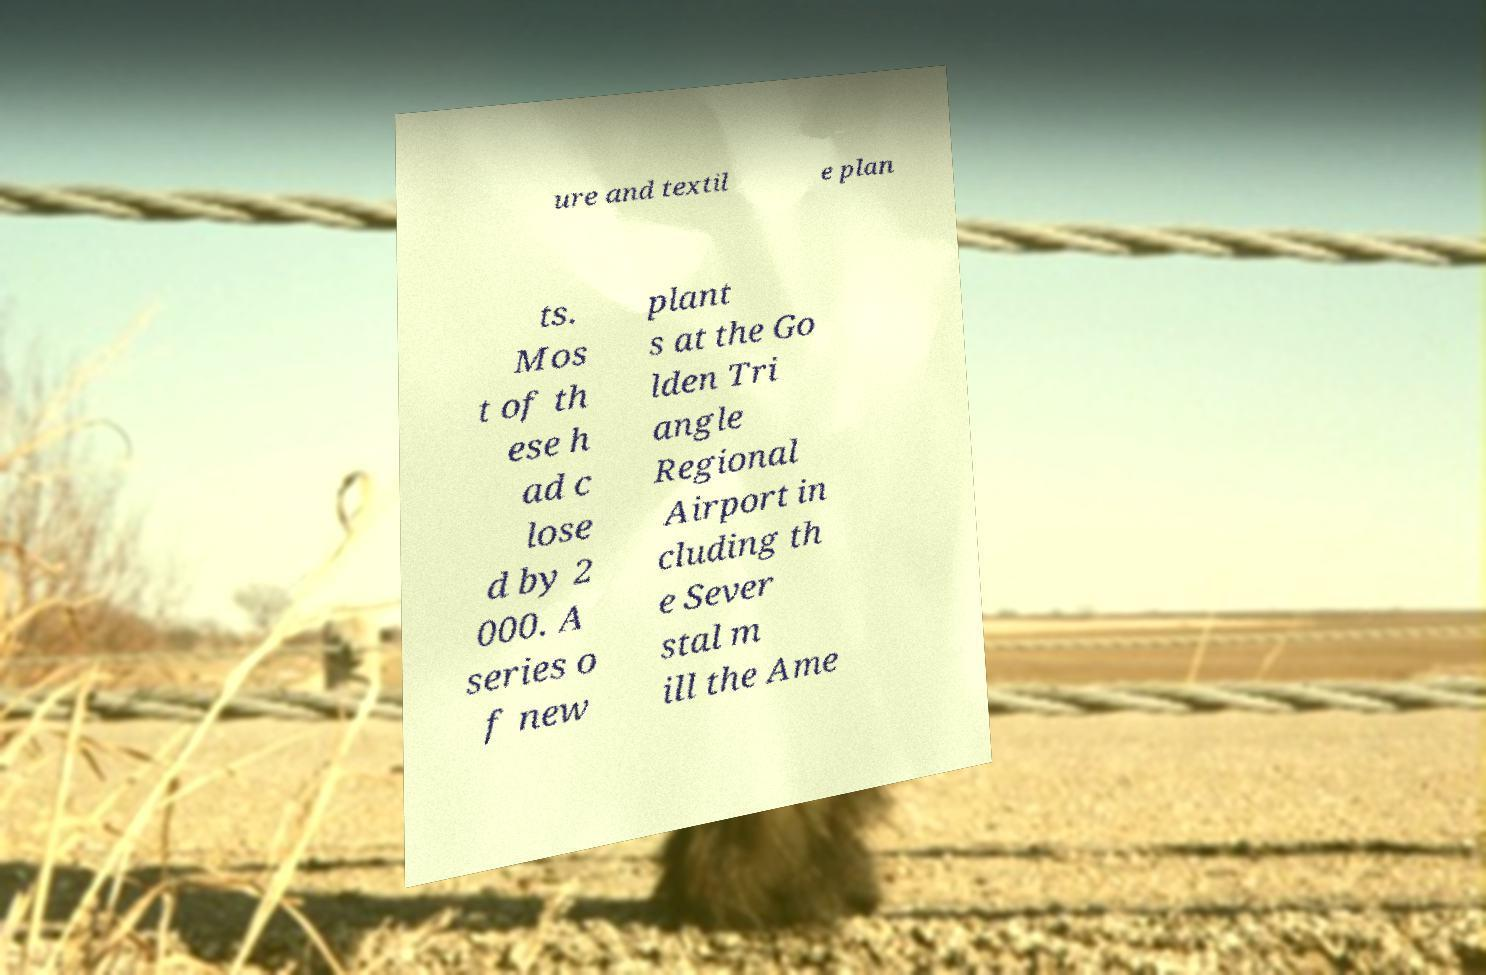Please read and relay the text visible in this image. What does it say? ure and textil e plan ts. Mos t of th ese h ad c lose d by 2 000. A series o f new plant s at the Go lden Tri angle Regional Airport in cluding th e Sever stal m ill the Ame 